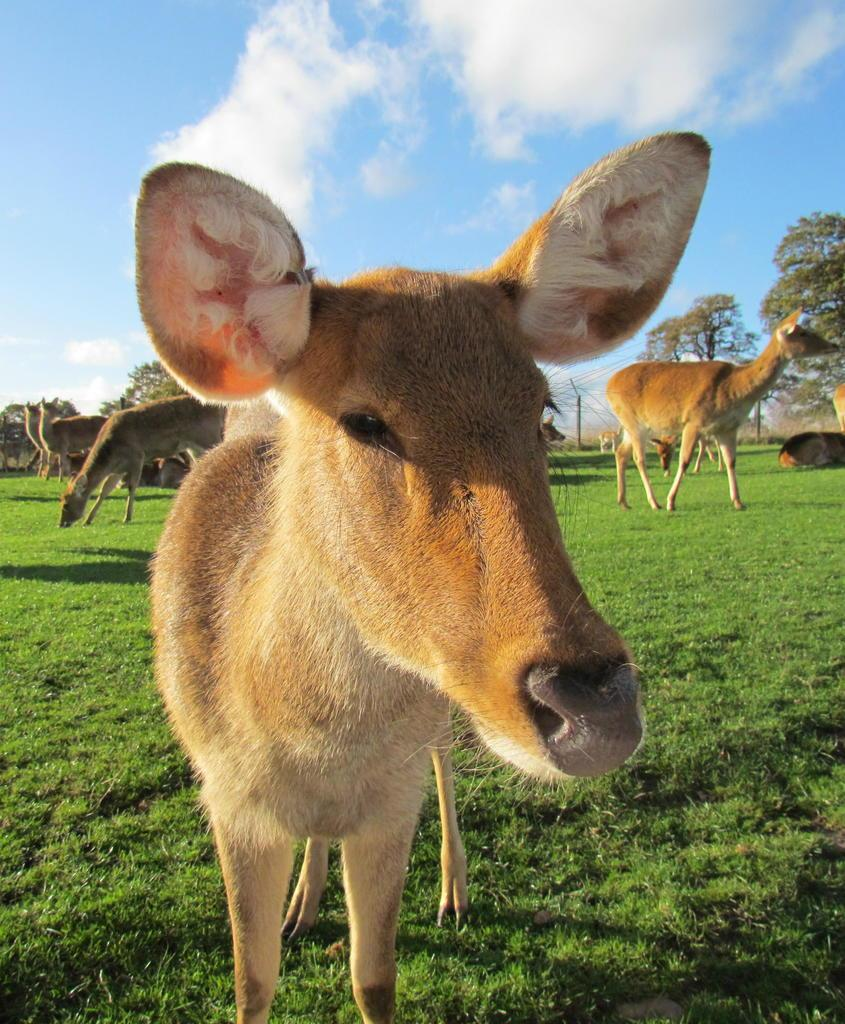What type of living organisms can be seen in the image? There are animals in the image. What colors are the animals in the image? The animals are in brown and cream color. What can be seen in the background of the image? There is grass and trees in the background of the image. What is the color of the sky in the image? The sky is blue and white in color. What type of cloth is being cut with scissors in the image? There is no cloth or scissors present in the image. What type of precipitation is falling from the sky in the image? There is no precipitation visible in the image; the sky is blue and white. 